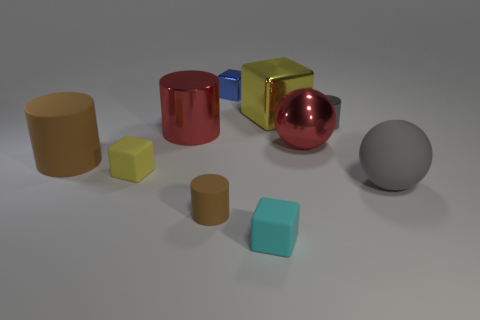How many other things are there of the same material as the big gray object?
Provide a succinct answer. 4. Is there anything else that has the same size as the red sphere?
Make the answer very short. Yes. There is a brown thing on the left side of the red metallic thing behind the ball to the left of the large gray rubber ball; what is its shape?
Provide a succinct answer. Cylinder. How many things are matte objects that are to the left of the large gray rubber thing or small matte cubes behind the cyan matte thing?
Provide a succinct answer. 4. There is a gray rubber ball; is its size the same as the red shiny cylinder left of the gray ball?
Make the answer very short. Yes. Are the large cylinder behind the big red shiny sphere and the yellow object in front of the tiny gray object made of the same material?
Your response must be concise. No. Are there the same number of big rubber spheres that are on the left side of the small brown rubber cylinder and gray cylinders that are on the left side of the red ball?
Give a very brief answer. Yes. What number of other matte blocks have the same color as the large cube?
Keep it short and to the point. 1. There is a ball that is the same color as the large shiny cylinder; what is its material?
Keep it short and to the point. Metal. How many rubber things are either large purple things or tiny blocks?
Your answer should be very brief. 2. 